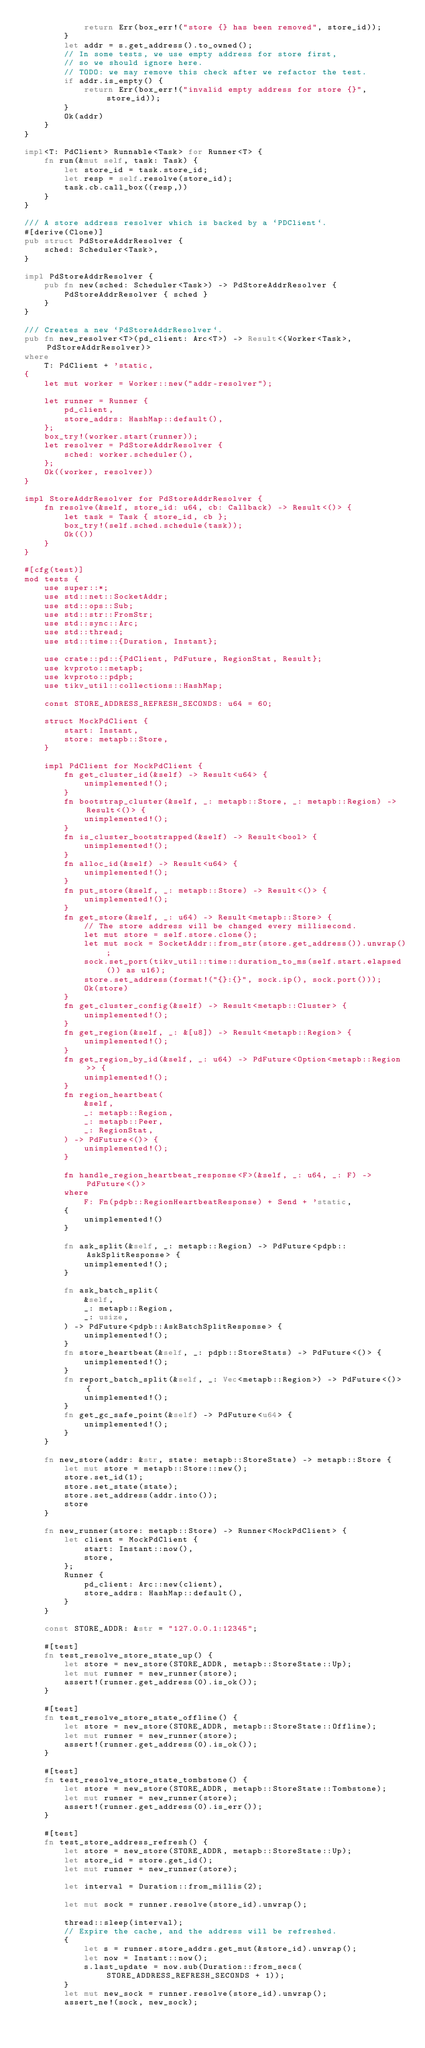Convert code to text. <code><loc_0><loc_0><loc_500><loc_500><_Rust_>            return Err(box_err!("store {} has been removed", store_id));
        }
        let addr = s.get_address().to_owned();
        // In some tests, we use empty address for store first,
        // so we should ignore here.
        // TODO: we may remove this check after we refactor the test.
        if addr.is_empty() {
            return Err(box_err!("invalid empty address for store {}", store_id));
        }
        Ok(addr)
    }
}

impl<T: PdClient> Runnable<Task> for Runner<T> {
    fn run(&mut self, task: Task) {
        let store_id = task.store_id;
        let resp = self.resolve(store_id);
        task.cb.call_box((resp,))
    }
}

/// A store address resolver which is backed by a `PDClient`.
#[derive(Clone)]
pub struct PdStoreAddrResolver {
    sched: Scheduler<Task>,
}

impl PdStoreAddrResolver {
    pub fn new(sched: Scheduler<Task>) -> PdStoreAddrResolver {
        PdStoreAddrResolver { sched }
    }
}

/// Creates a new `PdStoreAddrResolver`.
pub fn new_resolver<T>(pd_client: Arc<T>) -> Result<(Worker<Task>, PdStoreAddrResolver)>
where
    T: PdClient + 'static,
{
    let mut worker = Worker::new("addr-resolver");

    let runner = Runner {
        pd_client,
        store_addrs: HashMap::default(),
    };
    box_try!(worker.start(runner));
    let resolver = PdStoreAddrResolver {
        sched: worker.scheduler(),
    };
    Ok((worker, resolver))
}

impl StoreAddrResolver for PdStoreAddrResolver {
    fn resolve(&self, store_id: u64, cb: Callback) -> Result<()> {
        let task = Task { store_id, cb };
        box_try!(self.sched.schedule(task));
        Ok(())
    }
}

#[cfg(test)]
mod tests {
    use super::*;
    use std::net::SocketAddr;
    use std::ops::Sub;
    use std::str::FromStr;
    use std::sync::Arc;
    use std::thread;
    use std::time::{Duration, Instant};

    use crate::pd::{PdClient, PdFuture, RegionStat, Result};
    use kvproto::metapb;
    use kvproto::pdpb;
    use tikv_util::collections::HashMap;

    const STORE_ADDRESS_REFRESH_SECONDS: u64 = 60;

    struct MockPdClient {
        start: Instant,
        store: metapb::Store,
    }

    impl PdClient for MockPdClient {
        fn get_cluster_id(&self) -> Result<u64> {
            unimplemented!();
        }
        fn bootstrap_cluster(&self, _: metapb::Store, _: metapb::Region) -> Result<()> {
            unimplemented!();
        }
        fn is_cluster_bootstrapped(&self) -> Result<bool> {
            unimplemented!();
        }
        fn alloc_id(&self) -> Result<u64> {
            unimplemented!();
        }
        fn put_store(&self, _: metapb::Store) -> Result<()> {
            unimplemented!();
        }
        fn get_store(&self, _: u64) -> Result<metapb::Store> {
            // The store address will be changed every millisecond.
            let mut store = self.store.clone();
            let mut sock = SocketAddr::from_str(store.get_address()).unwrap();
            sock.set_port(tikv_util::time::duration_to_ms(self.start.elapsed()) as u16);
            store.set_address(format!("{}:{}", sock.ip(), sock.port()));
            Ok(store)
        }
        fn get_cluster_config(&self) -> Result<metapb::Cluster> {
            unimplemented!();
        }
        fn get_region(&self, _: &[u8]) -> Result<metapb::Region> {
            unimplemented!();
        }
        fn get_region_by_id(&self, _: u64) -> PdFuture<Option<metapb::Region>> {
            unimplemented!();
        }
        fn region_heartbeat(
            &self,
            _: metapb::Region,
            _: metapb::Peer,
            _: RegionStat,
        ) -> PdFuture<()> {
            unimplemented!();
        }

        fn handle_region_heartbeat_response<F>(&self, _: u64, _: F) -> PdFuture<()>
        where
            F: Fn(pdpb::RegionHeartbeatResponse) + Send + 'static,
        {
            unimplemented!()
        }

        fn ask_split(&self, _: metapb::Region) -> PdFuture<pdpb::AskSplitResponse> {
            unimplemented!();
        }

        fn ask_batch_split(
            &self,
            _: metapb::Region,
            _: usize,
        ) -> PdFuture<pdpb::AskBatchSplitResponse> {
            unimplemented!();
        }
        fn store_heartbeat(&self, _: pdpb::StoreStats) -> PdFuture<()> {
            unimplemented!();
        }
        fn report_batch_split(&self, _: Vec<metapb::Region>) -> PdFuture<()> {
            unimplemented!();
        }
        fn get_gc_safe_point(&self) -> PdFuture<u64> {
            unimplemented!();
        }
    }

    fn new_store(addr: &str, state: metapb::StoreState) -> metapb::Store {
        let mut store = metapb::Store::new();
        store.set_id(1);
        store.set_state(state);
        store.set_address(addr.into());
        store
    }

    fn new_runner(store: metapb::Store) -> Runner<MockPdClient> {
        let client = MockPdClient {
            start: Instant::now(),
            store,
        };
        Runner {
            pd_client: Arc::new(client),
            store_addrs: HashMap::default(),
        }
    }

    const STORE_ADDR: &str = "127.0.0.1:12345";

    #[test]
    fn test_resolve_store_state_up() {
        let store = new_store(STORE_ADDR, metapb::StoreState::Up);
        let mut runner = new_runner(store);
        assert!(runner.get_address(0).is_ok());
    }

    #[test]
    fn test_resolve_store_state_offline() {
        let store = new_store(STORE_ADDR, metapb::StoreState::Offline);
        let mut runner = new_runner(store);
        assert!(runner.get_address(0).is_ok());
    }

    #[test]
    fn test_resolve_store_state_tombstone() {
        let store = new_store(STORE_ADDR, metapb::StoreState::Tombstone);
        let mut runner = new_runner(store);
        assert!(runner.get_address(0).is_err());
    }

    #[test]
    fn test_store_address_refresh() {
        let store = new_store(STORE_ADDR, metapb::StoreState::Up);
        let store_id = store.get_id();
        let mut runner = new_runner(store);

        let interval = Duration::from_millis(2);

        let mut sock = runner.resolve(store_id).unwrap();

        thread::sleep(interval);
        // Expire the cache, and the address will be refreshed.
        {
            let s = runner.store_addrs.get_mut(&store_id).unwrap();
            let now = Instant::now();
            s.last_update = now.sub(Duration::from_secs(STORE_ADDRESS_REFRESH_SECONDS + 1));
        }
        let mut new_sock = runner.resolve(store_id).unwrap();
        assert_ne!(sock, new_sock);
</code> 